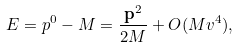Convert formula to latex. <formula><loc_0><loc_0><loc_500><loc_500>E = p ^ { 0 } - M = \frac { \mathbf p ^ { 2 } } { 2 M } + O ( M v ^ { 4 } ) ,</formula> 